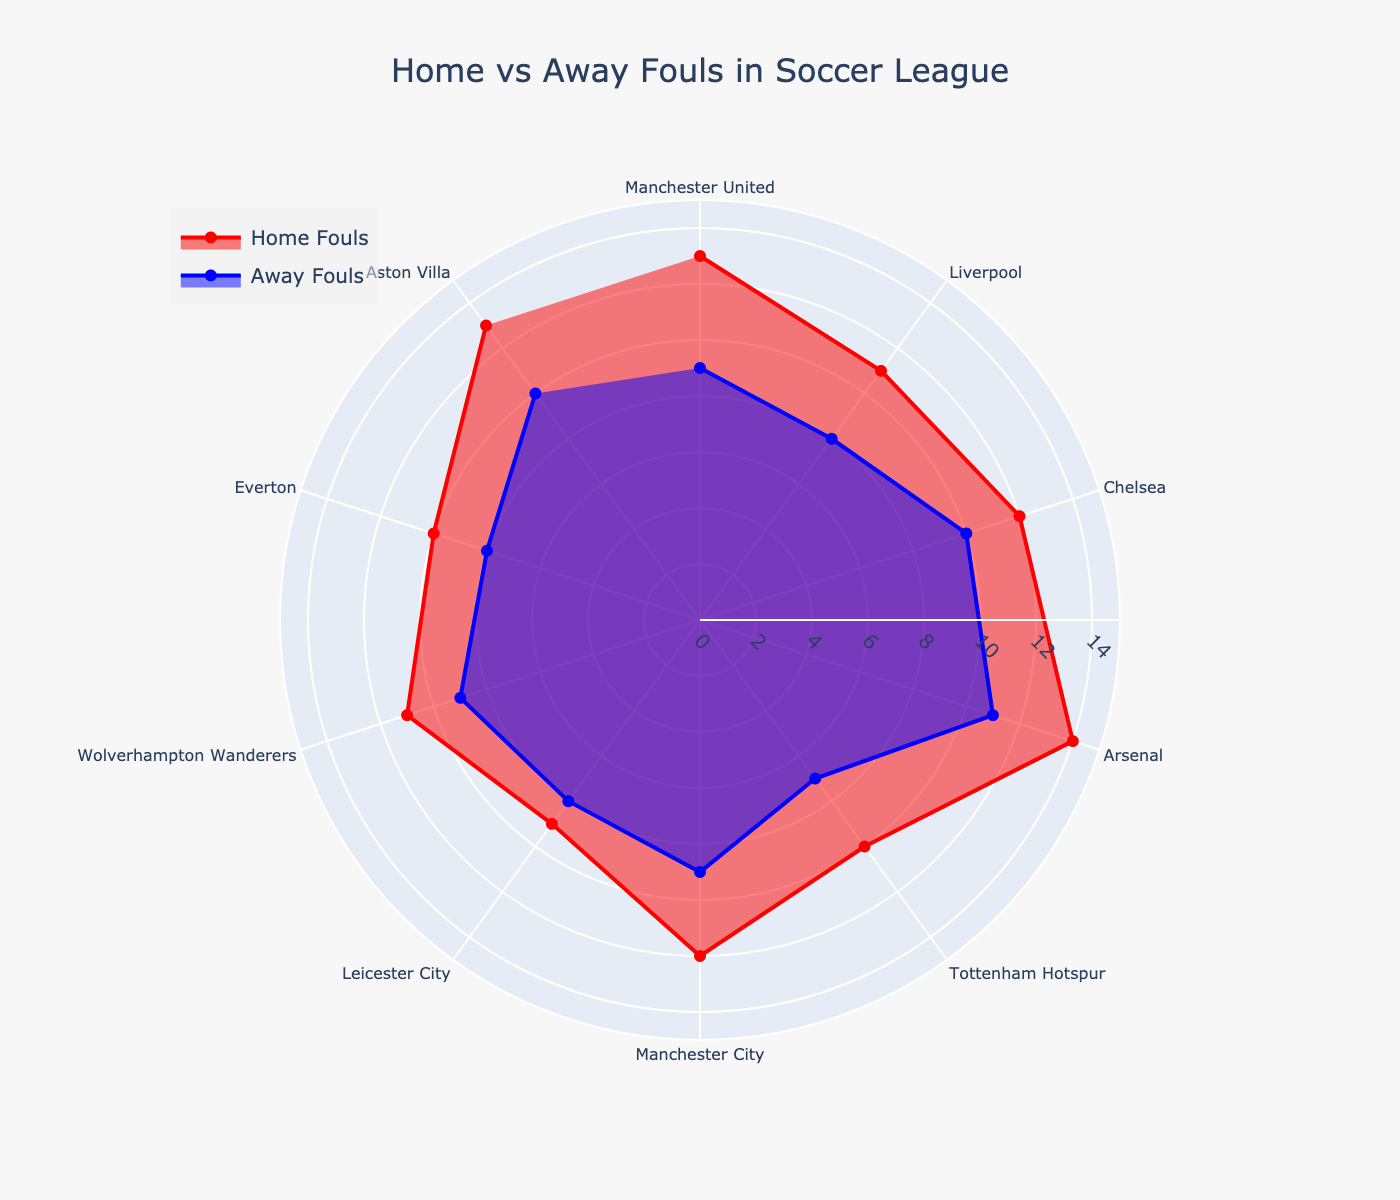What is the title of the chart? The title of the chart is typically found at the top center of the figure. It provides a brief description of what the chart represents.
Answer: Home vs Away Fouls in Soccer League What are the colors used to represent home and away fouls? The color for home fouls is red, and the color for away fouls is blue. This information can be seen from the legend that usually appears on the chart.
Answer: Red and Blue Which team committed the most home fouls? To determine this, look at the peaks of the red area on the polar chart and find out the corresponding category. The highest peak will represent the team with the most home fouls.
Answer: Arsenal By how many fouls does Arsenal lead Chelsea in home fouls? Compare the home fouls of Arsenal and Chelsea. Arsenal has 14 home fouls and Chelsea has 12. Subtracting 12 from 14 gives the lead.
Answer: 2 fouls Which team has the smallest difference between home and away fouls? Calculate the difference between home and away fouls for each team. The team with the smallest difference will be recognized as having similar performance at both home and away games.
Answer: Leicester City Is there a trend where home teams commit more fouls than away teams? To identify this trend, visually inspect if the red areas (home fouls) consistently surpass the blue areas (away fouls) across most categories.
Answer: Yes What is the total number of home and away fouls committed by Aston Villa? Sum up the home and away fouls for Aston Villa. The data indicates 13 home fouls and 10 away fouls. Therefore, 13 + 10 = 23 fouls.
Answer: 23 fouls Which teams committed more away fouls than Leicester City? Leicester City committed 8 away fouls. Compare this with all other teams' away fouls. Teams with greater numbers will be listed.
Answer: Arsenal, Chelsea, Aston Villa What is the average number of home fouls committed by all teams? Sum the home fouls for all teams and then divide by the number of teams to calculate the average. The sum is 115, and with 10 teams, the average is 115/10 = 11.5 fouls.
Answer: 11.5 fouls Does any team have an equal number of home and away fouls? Check each team's data for equal home and away fouls. If a team's home fouls and away fouls match exactly, they fit this condition.
Answer: No 